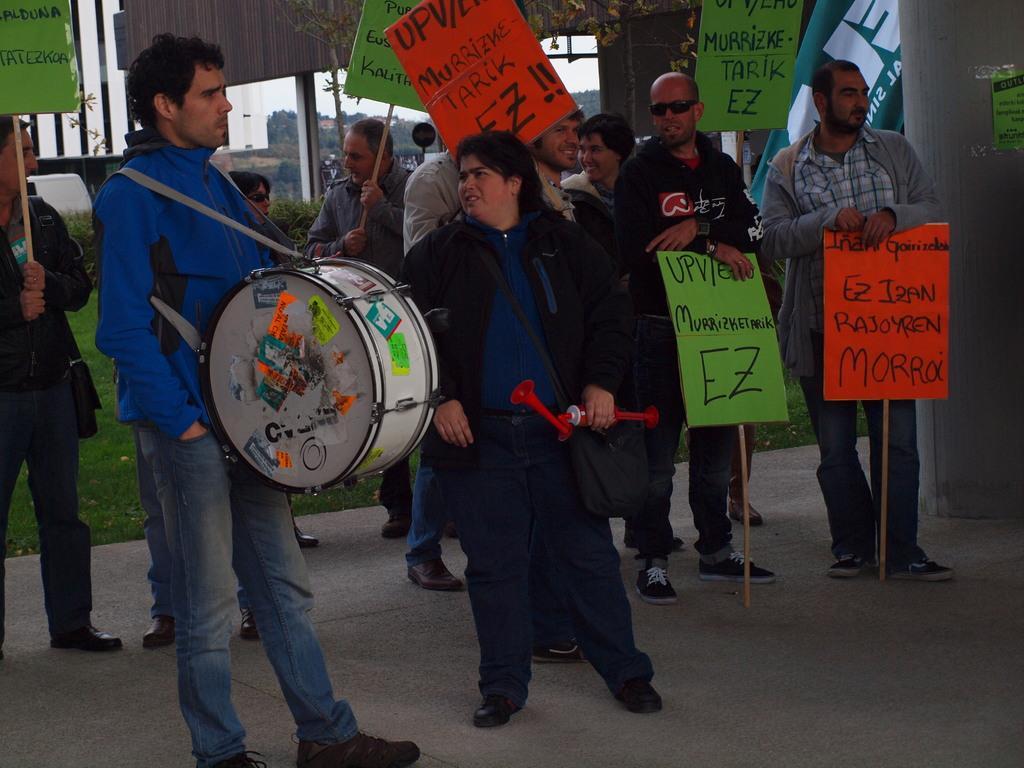Please provide a concise description of this image. In this picture we can see some persons standing on the road. This is the drum and she is carrying her bag. There is grass and there is a pillar. And these are the boards. 